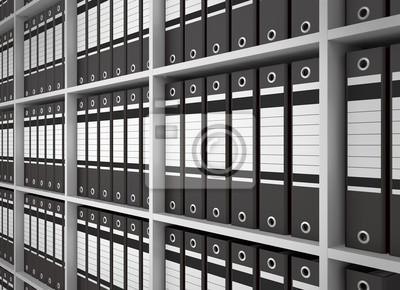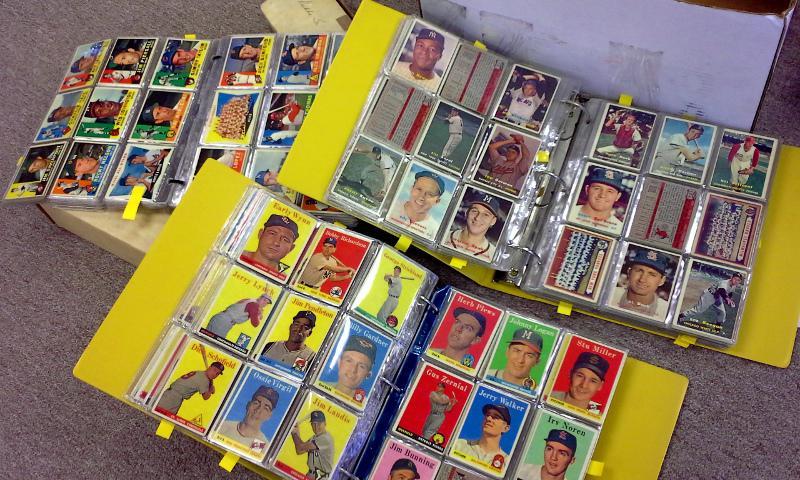The first image is the image on the left, the second image is the image on the right. Given the left and right images, does the statement "There are rows of colorful binders and an open binder." hold true? Answer yes or no. No. The first image is the image on the left, the second image is the image on the right. Evaluate the accuracy of this statement regarding the images: "One image shows a wall of shelves containing vertical binders, and the other image includes at least one open binder filled with plastic-sheeted items.". Is it true? Answer yes or no. Yes. 